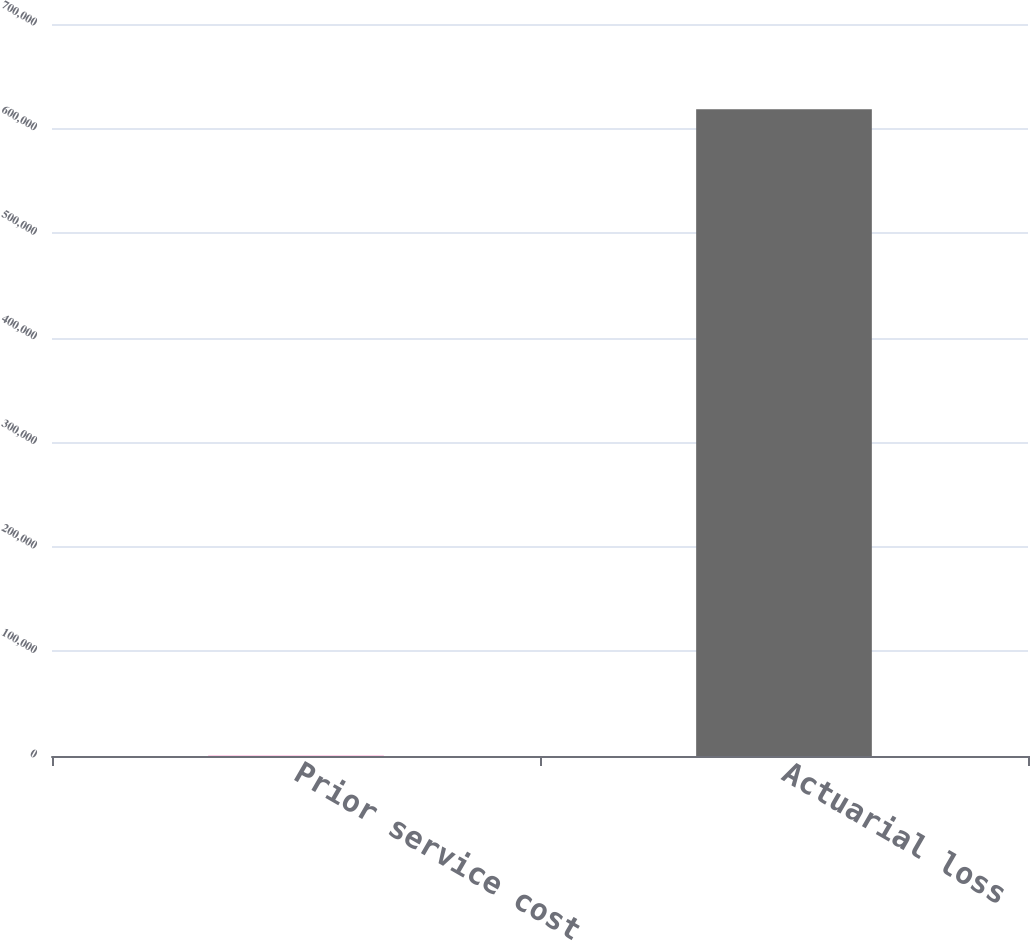<chart> <loc_0><loc_0><loc_500><loc_500><bar_chart><fcel>Prior service cost<fcel>Actuarial loss<nl><fcel>163<fcel>618579<nl></chart> 